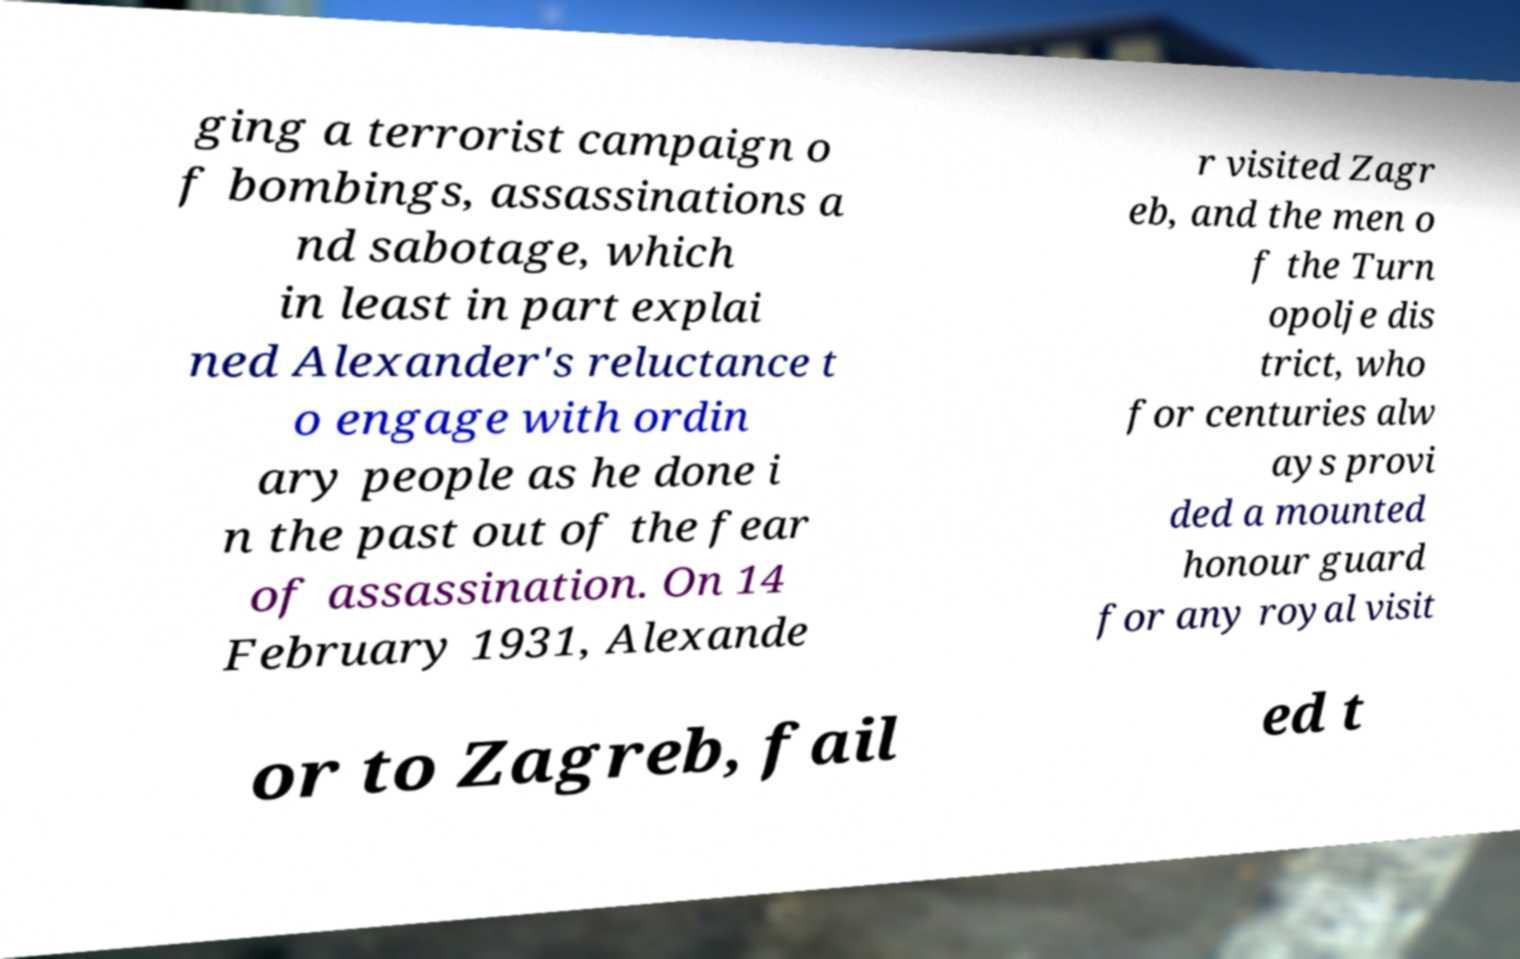Please identify and transcribe the text found in this image. ging a terrorist campaign o f bombings, assassinations a nd sabotage, which in least in part explai ned Alexander's reluctance t o engage with ordin ary people as he done i n the past out of the fear of assassination. On 14 February 1931, Alexande r visited Zagr eb, and the men o f the Turn opolje dis trict, who for centuries alw ays provi ded a mounted honour guard for any royal visit or to Zagreb, fail ed t 